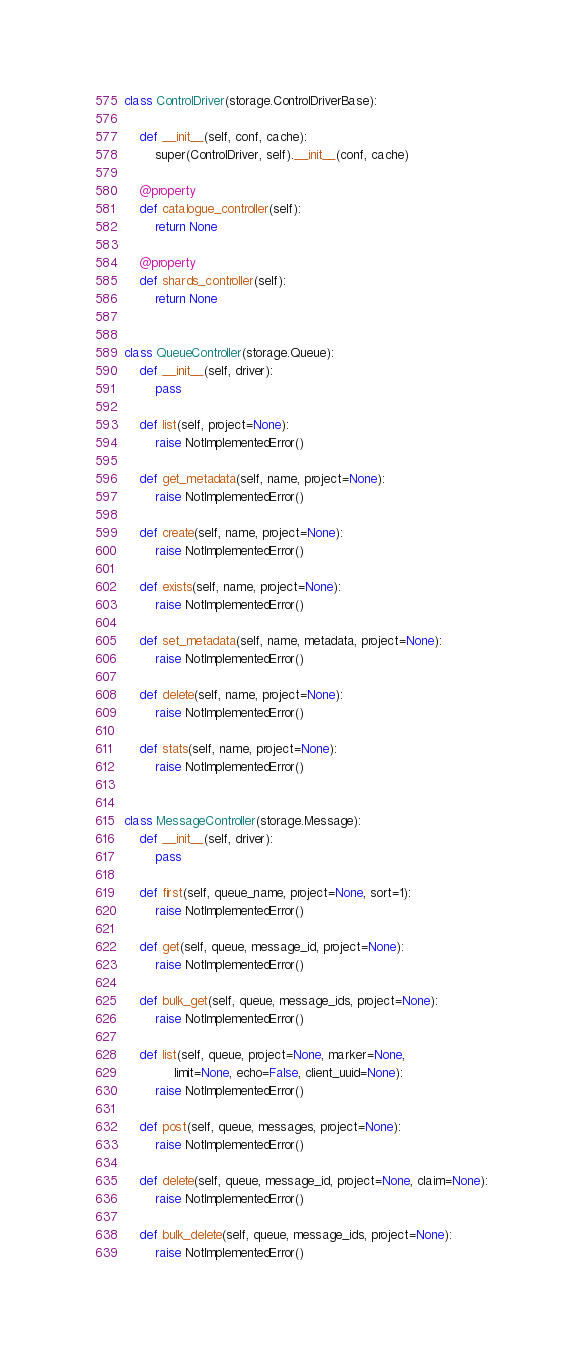<code> <loc_0><loc_0><loc_500><loc_500><_Python_>
class ControlDriver(storage.ControlDriverBase):

    def __init__(self, conf, cache):
        super(ControlDriver, self).__init__(conf, cache)

    @property
    def catalogue_controller(self):
        return None

    @property
    def shards_controller(self):
        return None


class QueueController(storage.Queue):
    def __init__(self, driver):
        pass

    def list(self, project=None):
        raise NotImplementedError()

    def get_metadata(self, name, project=None):
        raise NotImplementedError()

    def create(self, name, project=None):
        raise NotImplementedError()

    def exists(self, name, project=None):
        raise NotImplementedError()

    def set_metadata(self, name, metadata, project=None):
        raise NotImplementedError()

    def delete(self, name, project=None):
        raise NotImplementedError()

    def stats(self, name, project=None):
        raise NotImplementedError()


class MessageController(storage.Message):
    def __init__(self, driver):
        pass

    def first(self, queue_name, project=None, sort=1):
        raise NotImplementedError()

    def get(self, queue, message_id, project=None):
        raise NotImplementedError()

    def bulk_get(self, queue, message_ids, project=None):
        raise NotImplementedError()

    def list(self, queue, project=None, marker=None,
             limit=None, echo=False, client_uuid=None):
        raise NotImplementedError()

    def post(self, queue, messages, project=None):
        raise NotImplementedError()

    def delete(self, queue, message_id, project=None, claim=None):
        raise NotImplementedError()

    def bulk_delete(self, queue, message_ids, project=None):
        raise NotImplementedError()
</code> 